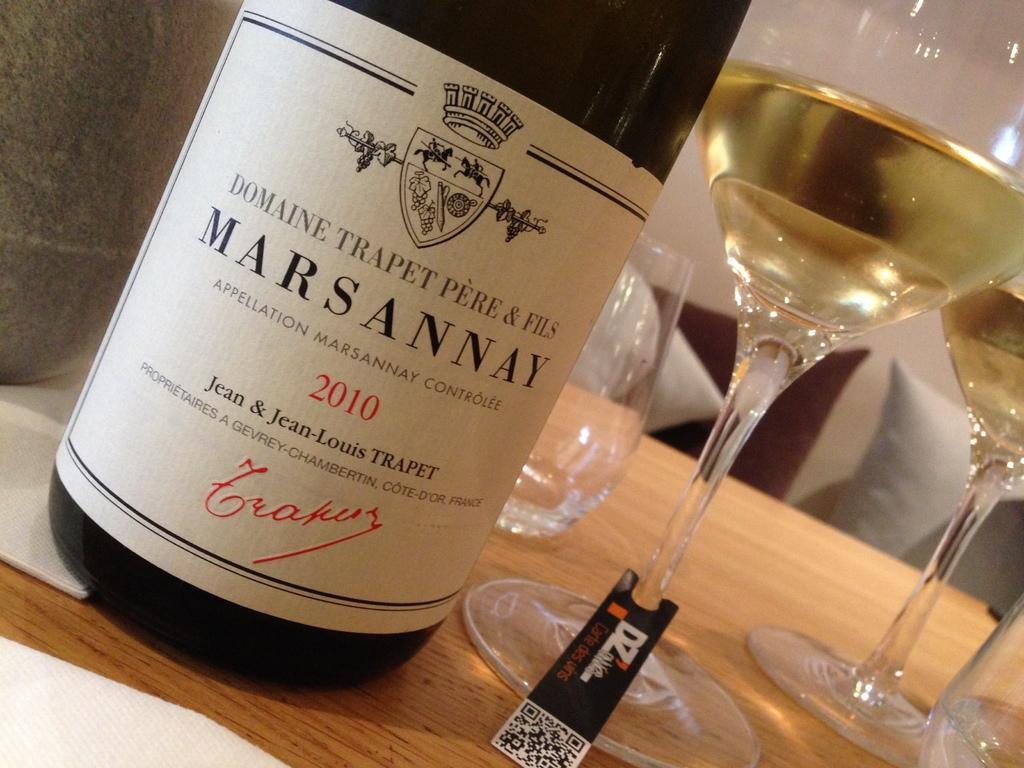Could you give a brief overview of what you see in this image? In this image we can see the bottle, glasses filled with liquid and placed on the wooden surface. 